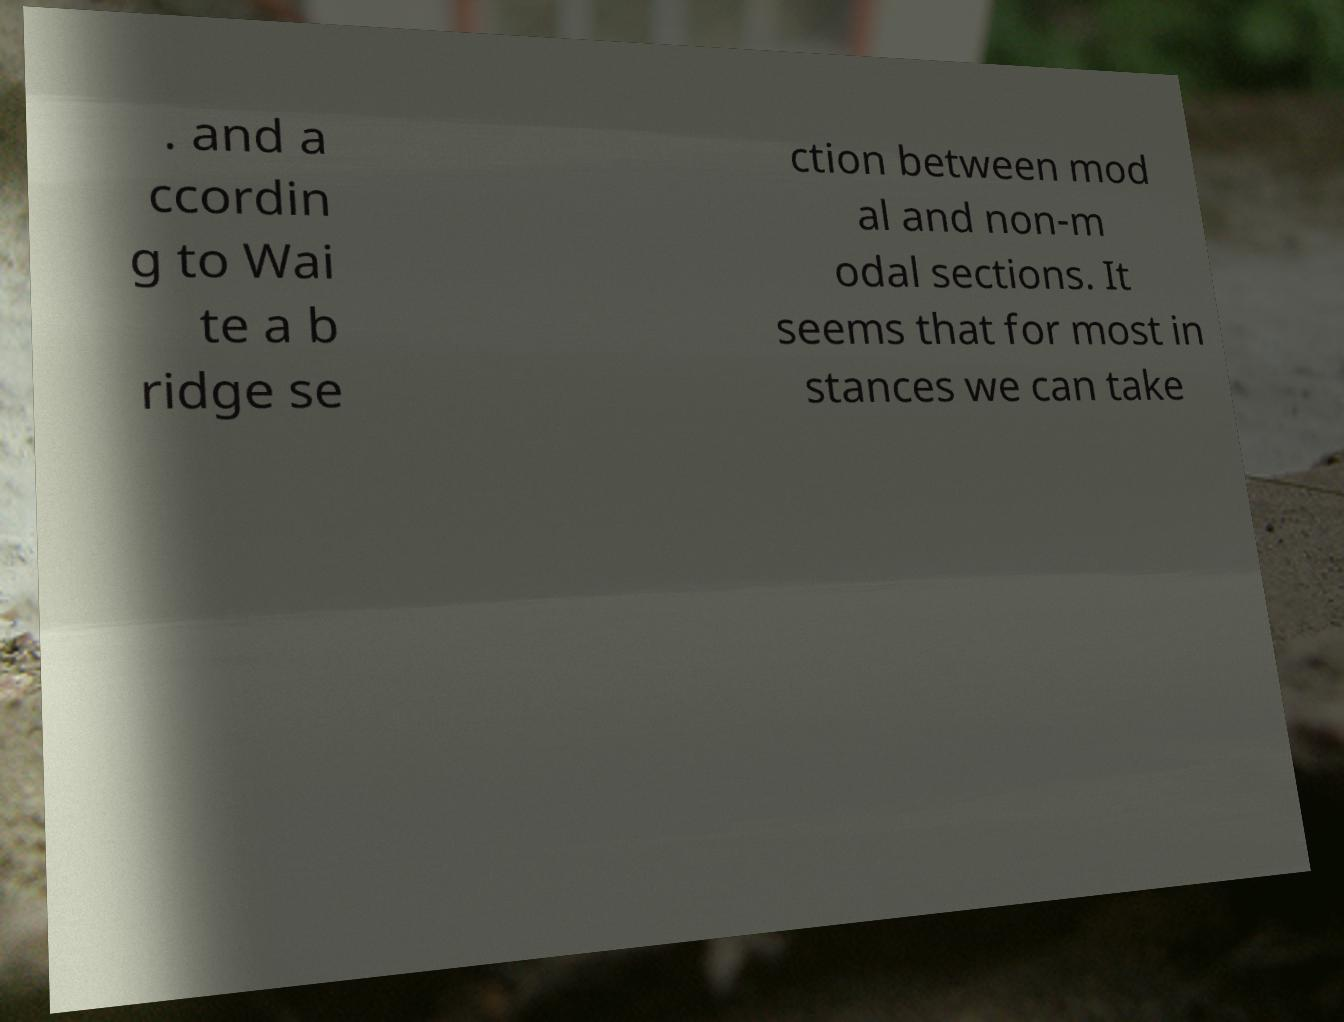Can you accurately transcribe the text from the provided image for me? . and a ccordin g to Wai te a b ridge se ction between mod al and non-m odal sections. It seems that for most in stances we can take 